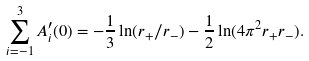Convert formula to latex. <formula><loc_0><loc_0><loc_500><loc_500>\sum _ { i = - 1 } ^ { 3 } A _ { i } ^ { \prime } ( 0 ) = - \frac { 1 } { 3 } \ln ( r _ { + } / r _ { - } ) - \frac { 1 } { 2 } \ln ( 4 \pi ^ { 2 } r _ { + } r _ { - } ) .</formula> 